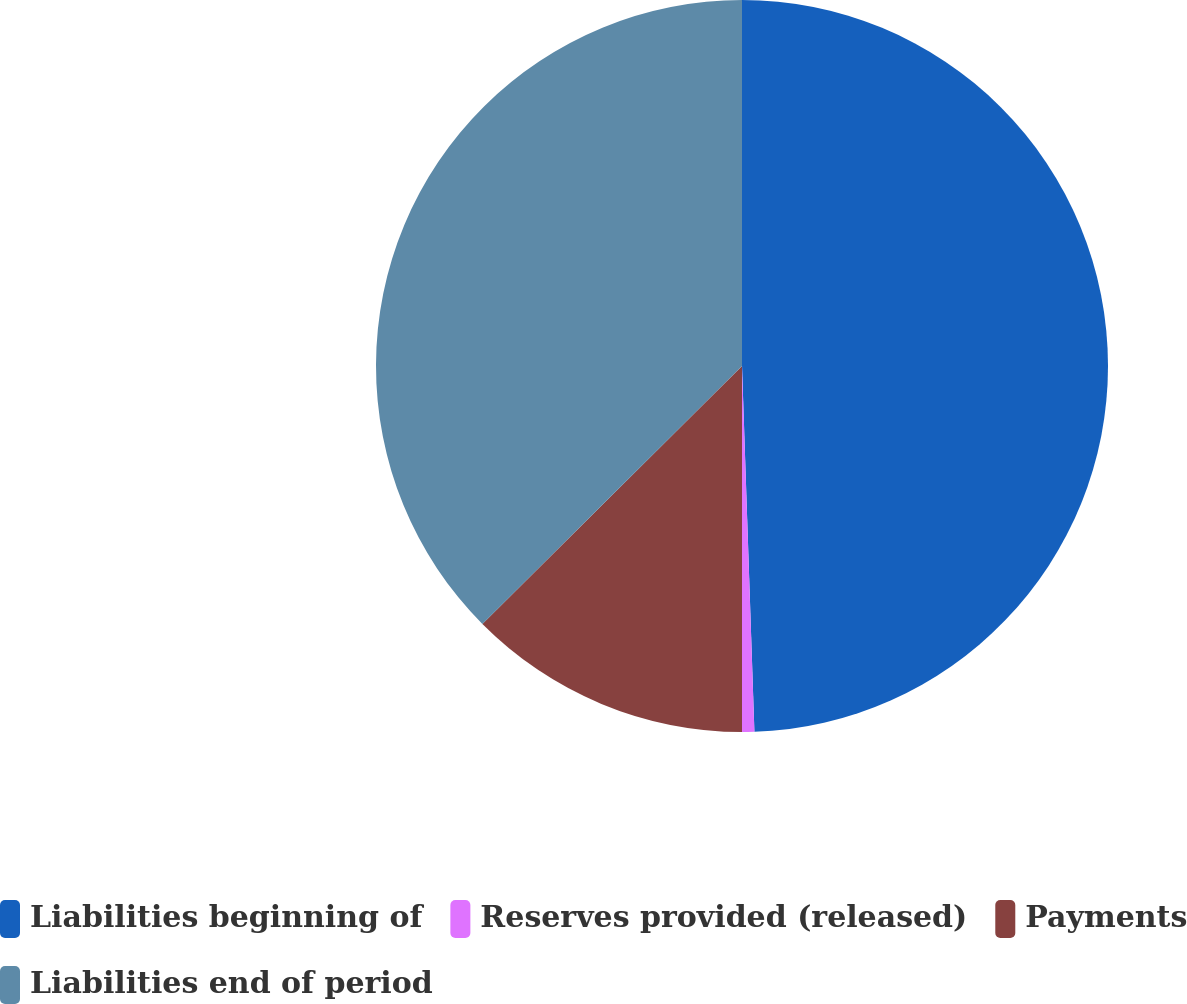Convert chart to OTSL. <chart><loc_0><loc_0><loc_500><loc_500><pie_chart><fcel>Liabilities beginning of<fcel>Reserves provided (released)<fcel>Payments<fcel>Liabilities end of period<nl><fcel>49.46%<fcel>0.54%<fcel>12.55%<fcel>37.45%<nl></chart> 